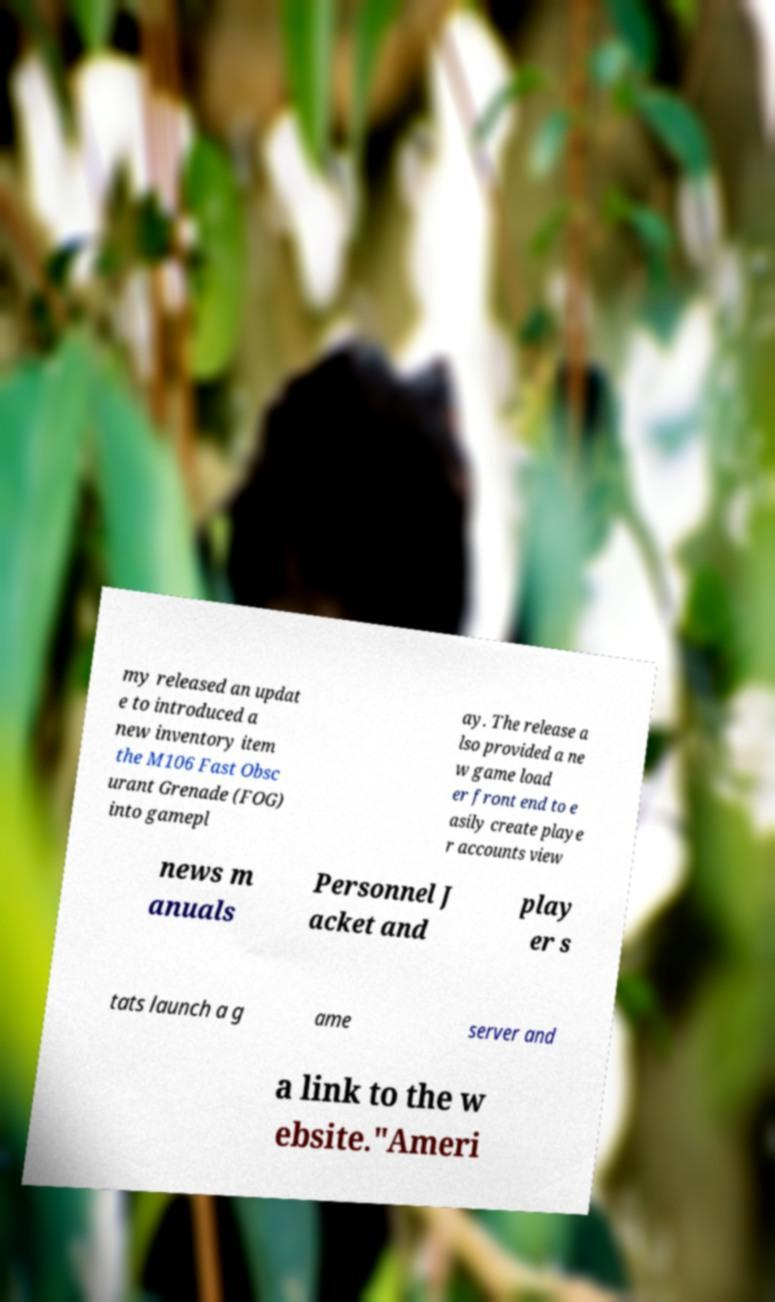What messages or text are displayed in this image? I need them in a readable, typed format. my released an updat e to introduced a new inventory item the M106 Fast Obsc urant Grenade (FOG) into gamepl ay. The release a lso provided a ne w game load er front end to e asily create playe r accounts view news m anuals Personnel J acket and play er s tats launch a g ame server and a link to the w ebsite."Ameri 